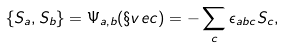Convert formula to latex. <formula><loc_0><loc_0><loc_500><loc_500>\{ S _ { a } , S _ { b } \} = \Psi _ { a , b } ( \S v e c ) = - \sum _ { c } \epsilon _ { a b c } S _ { c } ,</formula> 